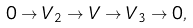<formula> <loc_0><loc_0><loc_500><loc_500>0 \to V _ { 2 } \to V \to V _ { 3 } \to 0 ,</formula> 